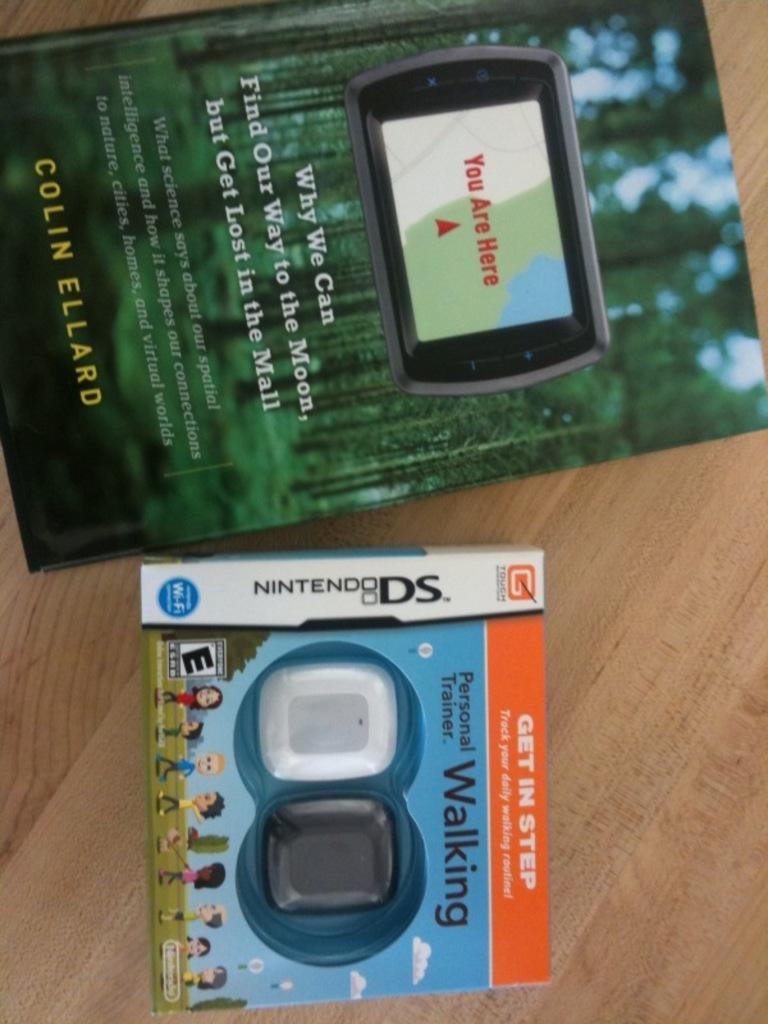<image>
Create a compact narrative representing the image presented. A book by Colin Ellard titled "You Are Here" next to a NintendoDS walking game. 